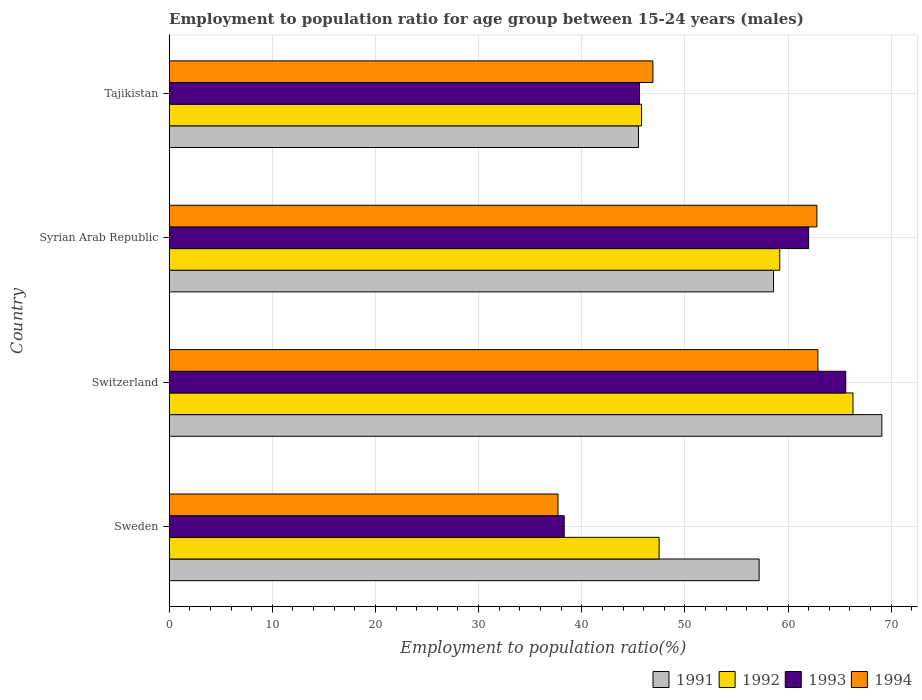How many different coloured bars are there?
Ensure brevity in your answer.  4. Are the number of bars on each tick of the Y-axis equal?
Offer a terse response. Yes. How many bars are there on the 4th tick from the top?
Provide a short and direct response. 4. How many bars are there on the 3rd tick from the bottom?
Offer a very short reply. 4. What is the label of the 1st group of bars from the top?
Provide a succinct answer. Tajikistan. What is the employment to population ratio in 1993 in Sweden?
Your answer should be very brief. 38.3. Across all countries, what is the maximum employment to population ratio in 1993?
Provide a short and direct response. 65.6. Across all countries, what is the minimum employment to population ratio in 1992?
Your answer should be compact. 45.8. In which country was the employment to population ratio in 1992 maximum?
Give a very brief answer. Switzerland. In which country was the employment to population ratio in 1993 minimum?
Keep it short and to the point. Sweden. What is the total employment to population ratio in 1991 in the graph?
Offer a terse response. 230.4. What is the difference between the employment to population ratio in 1992 in Switzerland and that in Syrian Arab Republic?
Provide a succinct answer. 7.1. What is the difference between the employment to population ratio in 1993 in Switzerland and the employment to population ratio in 1994 in Syrian Arab Republic?
Your response must be concise. 2.8. What is the average employment to population ratio in 1991 per country?
Provide a succinct answer. 57.6. What is the difference between the employment to population ratio in 1994 and employment to population ratio in 1991 in Syrian Arab Republic?
Give a very brief answer. 4.2. What is the ratio of the employment to population ratio in 1991 in Switzerland to that in Syrian Arab Republic?
Your response must be concise. 1.18. What is the difference between the highest and the second highest employment to population ratio in 1992?
Give a very brief answer. 7.1. What is the difference between the highest and the lowest employment to population ratio in 1991?
Offer a terse response. 23.6. What does the 3rd bar from the top in Switzerland represents?
Ensure brevity in your answer.  1992. Are all the bars in the graph horizontal?
Ensure brevity in your answer.  Yes. What is the difference between two consecutive major ticks on the X-axis?
Your answer should be very brief. 10. Where does the legend appear in the graph?
Make the answer very short. Bottom right. How many legend labels are there?
Keep it short and to the point. 4. What is the title of the graph?
Ensure brevity in your answer.  Employment to population ratio for age group between 15-24 years (males). What is the label or title of the X-axis?
Your response must be concise. Employment to population ratio(%). What is the Employment to population ratio(%) in 1991 in Sweden?
Provide a short and direct response. 57.2. What is the Employment to population ratio(%) in 1992 in Sweden?
Offer a very short reply. 47.5. What is the Employment to population ratio(%) of 1993 in Sweden?
Make the answer very short. 38.3. What is the Employment to population ratio(%) of 1994 in Sweden?
Offer a very short reply. 37.7. What is the Employment to population ratio(%) in 1991 in Switzerland?
Offer a terse response. 69.1. What is the Employment to population ratio(%) in 1992 in Switzerland?
Keep it short and to the point. 66.3. What is the Employment to population ratio(%) of 1993 in Switzerland?
Ensure brevity in your answer.  65.6. What is the Employment to population ratio(%) in 1994 in Switzerland?
Provide a succinct answer. 62.9. What is the Employment to population ratio(%) of 1991 in Syrian Arab Republic?
Give a very brief answer. 58.6. What is the Employment to population ratio(%) of 1992 in Syrian Arab Republic?
Provide a succinct answer. 59.2. What is the Employment to population ratio(%) of 1994 in Syrian Arab Republic?
Your response must be concise. 62.8. What is the Employment to population ratio(%) of 1991 in Tajikistan?
Ensure brevity in your answer.  45.5. What is the Employment to population ratio(%) of 1992 in Tajikistan?
Offer a terse response. 45.8. What is the Employment to population ratio(%) in 1993 in Tajikistan?
Offer a terse response. 45.6. What is the Employment to population ratio(%) in 1994 in Tajikistan?
Offer a terse response. 46.9. Across all countries, what is the maximum Employment to population ratio(%) of 1991?
Give a very brief answer. 69.1. Across all countries, what is the maximum Employment to population ratio(%) of 1992?
Ensure brevity in your answer.  66.3. Across all countries, what is the maximum Employment to population ratio(%) in 1993?
Offer a terse response. 65.6. Across all countries, what is the maximum Employment to population ratio(%) in 1994?
Give a very brief answer. 62.9. Across all countries, what is the minimum Employment to population ratio(%) in 1991?
Ensure brevity in your answer.  45.5. Across all countries, what is the minimum Employment to population ratio(%) in 1992?
Offer a very short reply. 45.8. Across all countries, what is the minimum Employment to population ratio(%) of 1993?
Provide a short and direct response. 38.3. Across all countries, what is the minimum Employment to population ratio(%) of 1994?
Offer a very short reply. 37.7. What is the total Employment to population ratio(%) of 1991 in the graph?
Your answer should be very brief. 230.4. What is the total Employment to population ratio(%) of 1992 in the graph?
Provide a short and direct response. 218.8. What is the total Employment to population ratio(%) in 1993 in the graph?
Provide a short and direct response. 211.5. What is the total Employment to population ratio(%) of 1994 in the graph?
Provide a succinct answer. 210.3. What is the difference between the Employment to population ratio(%) of 1992 in Sweden and that in Switzerland?
Ensure brevity in your answer.  -18.8. What is the difference between the Employment to population ratio(%) in 1993 in Sweden and that in Switzerland?
Provide a succinct answer. -27.3. What is the difference between the Employment to population ratio(%) of 1994 in Sweden and that in Switzerland?
Offer a very short reply. -25.2. What is the difference between the Employment to population ratio(%) of 1992 in Sweden and that in Syrian Arab Republic?
Ensure brevity in your answer.  -11.7. What is the difference between the Employment to population ratio(%) in 1993 in Sweden and that in Syrian Arab Republic?
Ensure brevity in your answer.  -23.7. What is the difference between the Employment to population ratio(%) in 1994 in Sweden and that in Syrian Arab Republic?
Your answer should be very brief. -25.1. What is the difference between the Employment to population ratio(%) in 1991 in Sweden and that in Tajikistan?
Make the answer very short. 11.7. What is the difference between the Employment to population ratio(%) in 1992 in Sweden and that in Tajikistan?
Offer a very short reply. 1.7. What is the difference between the Employment to population ratio(%) of 1993 in Sweden and that in Tajikistan?
Ensure brevity in your answer.  -7.3. What is the difference between the Employment to population ratio(%) in 1994 in Sweden and that in Tajikistan?
Provide a succinct answer. -9.2. What is the difference between the Employment to population ratio(%) of 1991 in Switzerland and that in Syrian Arab Republic?
Offer a terse response. 10.5. What is the difference between the Employment to population ratio(%) of 1991 in Switzerland and that in Tajikistan?
Offer a very short reply. 23.6. What is the difference between the Employment to population ratio(%) in 1992 in Switzerland and that in Tajikistan?
Offer a very short reply. 20.5. What is the difference between the Employment to population ratio(%) in 1993 in Switzerland and that in Tajikistan?
Your answer should be compact. 20. What is the difference between the Employment to population ratio(%) in 1994 in Switzerland and that in Tajikistan?
Your response must be concise. 16. What is the difference between the Employment to population ratio(%) in 1993 in Syrian Arab Republic and that in Tajikistan?
Provide a succinct answer. 16.4. What is the difference between the Employment to population ratio(%) of 1991 in Sweden and the Employment to population ratio(%) of 1992 in Switzerland?
Your answer should be compact. -9.1. What is the difference between the Employment to population ratio(%) of 1991 in Sweden and the Employment to population ratio(%) of 1994 in Switzerland?
Your answer should be very brief. -5.7. What is the difference between the Employment to population ratio(%) of 1992 in Sweden and the Employment to population ratio(%) of 1993 in Switzerland?
Give a very brief answer. -18.1. What is the difference between the Employment to population ratio(%) of 1992 in Sweden and the Employment to population ratio(%) of 1994 in Switzerland?
Keep it short and to the point. -15.4. What is the difference between the Employment to population ratio(%) of 1993 in Sweden and the Employment to population ratio(%) of 1994 in Switzerland?
Provide a short and direct response. -24.6. What is the difference between the Employment to population ratio(%) in 1991 in Sweden and the Employment to population ratio(%) in 1992 in Syrian Arab Republic?
Offer a very short reply. -2. What is the difference between the Employment to population ratio(%) in 1991 in Sweden and the Employment to population ratio(%) in 1993 in Syrian Arab Republic?
Your answer should be very brief. -4.8. What is the difference between the Employment to population ratio(%) in 1991 in Sweden and the Employment to population ratio(%) in 1994 in Syrian Arab Republic?
Your response must be concise. -5.6. What is the difference between the Employment to population ratio(%) in 1992 in Sweden and the Employment to population ratio(%) in 1993 in Syrian Arab Republic?
Keep it short and to the point. -14.5. What is the difference between the Employment to population ratio(%) of 1992 in Sweden and the Employment to population ratio(%) of 1994 in Syrian Arab Republic?
Provide a succinct answer. -15.3. What is the difference between the Employment to population ratio(%) in 1993 in Sweden and the Employment to population ratio(%) in 1994 in Syrian Arab Republic?
Your answer should be very brief. -24.5. What is the difference between the Employment to population ratio(%) in 1991 in Sweden and the Employment to population ratio(%) in 1994 in Tajikistan?
Provide a short and direct response. 10.3. What is the difference between the Employment to population ratio(%) of 1992 in Sweden and the Employment to population ratio(%) of 1993 in Tajikistan?
Your answer should be very brief. 1.9. What is the difference between the Employment to population ratio(%) of 1993 in Sweden and the Employment to population ratio(%) of 1994 in Tajikistan?
Provide a succinct answer. -8.6. What is the difference between the Employment to population ratio(%) of 1991 in Switzerland and the Employment to population ratio(%) of 1992 in Syrian Arab Republic?
Keep it short and to the point. 9.9. What is the difference between the Employment to population ratio(%) of 1991 in Switzerland and the Employment to population ratio(%) of 1994 in Syrian Arab Republic?
Make the answer very short. 6.3. What is the difference between the Employment to population ratio(%) in 1993 in Switzerland and the Employment to population ratio(%) in 1994 in Syrian Arab Republic?
Your response must be concise. 2.8. What is the difference between the Employment to population ratio(%) in 1991 in Switzerland and the Employment to population ratio(%) in 1992 in Tajikistan?
Keep it short and to the point. 23.3. What is the difference between the Employment to population ratio(%) in 1992 in Switzerland and the Employment to population ratio(%) in 1993 in Tajikistan?
Offer a terse response. 20.7. What is the difference between the Employment to population ratio(%) of 1993 in Switzerland and the Employment to population ratio(%) of 1994 in Tajikistan?
Provide a succinct answer. 18.7. What is the difference between the Employment to population ratio(%) of 1991 in Syrian Arab Republic and the Employment to population ratio(%) of 1992 in Tajikistan?
Provide a short and direct response. 12.8. What is the difference between the Employment to population ratio(%) in 1991 in Syrian Arab Republic and the Employment to population ratio(%) in 1993 in Tajikistan?
Keep it short and to the point. 13. What is the difference between the Employment to population ratio(%) of 1992 in Syrian Arab Republic and the Employment to population ratio(%) of 1993 in Tajikistan?
Provide a short and direct response. 13.6. What is the difference between the Employment to population ratio(%) in 1992 in Syrian Arab Republic and the Employment to population ratio(%) in 1994 in Tajikistan?
Your response must be concise. 12.3. What is the average Employment to population ratio(%) of 1991 per country?
Your response must be concise. 57.6. What is the average Employment to population ratio(%) in 1992 per country?
Offer a very short reply. 54.7. What is the average Employment to population ratio(%) in 1993 per country?
Offer a very short reply. 52.88. What is the average Employment to population ratio(%) in 1994 per country?
Provide a short and direct response. 52.58. What is the difference between the Employment to population ratio(%) in 1991 and Employment to population ratio(%) in 1992 in Sweden?
Your answer should be compact. 9.7. What is the difference between the Employment to population ratio(%) in 1991 and Employment to population ratio(%) in 1993 in Sweden?
Your response must be concise. 18.9. What is the difference between the Employment to population ratio(%) in 1991 and Employment to population ratio(%) in 1994 in Sweden?
Your answer should be very brief. 19.5. What is the difference between the Employment to population ratio(%) of 1992 and Employment to population ratio(%) of 1993 in Sweden?
Offer a terse response. 9.2. What is the difference between the Employment to population ratio(%) in 1991 and Employment to population ratio(%) in 1993 in Switzerland?
Your answer should be very brief. 3.5. What is the difference between the Employment to population ratio(%) of 1992 and Employment to population ratio(%) of 1994 in Switzerland?
Ensure brevity in your answer.  3.4. What is the difference between the Employment to population ratio(%) of 1991 and Employment to population ratio(%) of 1993 in Syrian Arab Republic?
Your answer should be very brief. -3.4. What is the difference between the Employment to population ratio(%) of 1991 and Employment to population ratio(%) of 1994 in Syrian Arab Republic?
Your answer should be compact. -4.2. What is the difference between the Employment to population ratio(%) of 1991 and Employment to population ratio(%) of 1992 in Tajikistan?
Give a very brief answer. -0.3. What is the ratio of the Employment to population ratio(%) in 1991 in Sweden to that in Switzerland?
Ensure brevity in your answer.  0.83. What is the ratio of the Employment to population ratio(%) in 1992 in Sweden to that in Switzerland?
Your response must be concise. 0.72. What is the ratio of the Employment to population ratio(%) in 1993 in Sweden to that in Switzerland?
Keep it short and to the point. 0.58. What is the ratio of the Employment to population ratio(%) in 1994 in Sweden to that in Switzerland?
Your answer should be compact. 0.6. What is the ratio of the Employment to population ratio(%) of 1991 in Sweden to that in Syrian Arab Republic?
Your answer should be compact. 0.98. What is the ratio of the Employment to population ratio(%) in 1992 in Sweden to that in Syrian Arab Republic?
Your answer should be compact. 0.8. What is the ratio of the Employment to population ratio(%) in 1993 in Sweden to that in Syrian Arab Republic?
Provide a short and direct response. 0.62. What is the ratio of the Employment to population ratio(%) in 1994 in Sweden to that in Syrian Arab Republic?
Ensure brevity in your answer.  0.6. What is the ratio of the Employment to population ratio(%) of 1991 in Sweden to that in Tajikistan?
Make the answer very short. 1.26. What is the ratio of the Employment to population ratio(%) in 1992 in Sweden to that in Tajikistan?
Provide a succinct answer. 1.04. What is the ratio of the Employment to population ratio(%) in 1993 in Sweden to that in Tajikistan?
Your answer should be very brief. 0.84. What is the ratio of the Employment to population ratio(%) of 1994 in Sweden to that in Tajikistan?
Your answer should be compact. 0.8. What is the ratio of the Employment to population ratio(%) in 1991 in Switzerland to that in Syrian Arab Republic?
Offer a terse response. 1.18. What is the ratio of the Employment to population ratio(%) of 1992 in Switzerland to that in Syrian Arab Republic?
Offer a very short reply. 1.12. What is the ratio of the Employment to population ratio(%) of 1993 in Switzerland to that in Syrian Arab Republic?
Keep it short and to the point. 1.06. What is the ratio of the Employment to population ratio(%) of 1991 in Switzerland to that in Tajikistan?
Offer a terse response. 1.52. What is the ratio of the Employment to population ratio(%) in 1992 in Switzerland to that in Tajikistan?
Your answer should be very brief. 1.45. What is the ratio of the Employment to population ratio(%) in 1993 in Switzerland to that in Tajikistan?
Ensure brevity in your answer.  1.44. What is the ratio of the Employment to population ratio(%) of 1994 in Switzerland to that in Tajikistan?
Ensure brevity in your answer.  1.34. What is the ratio of the Employment to population ratio(%) in 1991 in Syrian Arab Republic to that in Tajikistan?
Provide a short and direct response. 1.29. What is the ratio of the Employment to population ratio(%) of 1992 in Syrian Arab Republic to that in Tajikistan?
Provide a succinct answer. 1.29. What is the ratio of the Employment to population ratio(%) of 1993 in Syrian Arab Republic to that in Tajikistan?
Your answer should be very brief. 1.36. What is the ratio of the Employment to population ratio(%) in 1994 in Syrian Arab Republic to that in Tajikistan?
Give a very brief answer. 1.34. What is the difference between the highest and the second highest Employment to population ratio(%) in 1991?
Your answer should be very brief. 10.5. What is the difference between the highest and the lowest Employment to population ratio(%) of 1991?
Your response must be concise. 23.6. What is the difference between the highest and the lowest Employment to population ratio(%) of 1992?
Make the answer very short. 20.5. What is the difference between the highest and the lowest Employment to population ratio(%) in 1993?
Offer a terse response. 27.3. What is the difference between the highest and the lowest Employment to population ratio(%) of 1994?
Your answer should be compact. 25.2. 